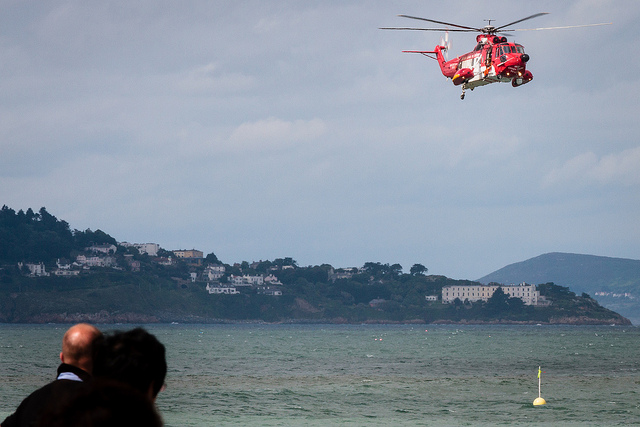<image>How high is the helicopter? It's uncertain how high the helicopter is, it could be anywhere from 50 to 500 feet. How high is the helicopter? It is unknown how high the helicopter is. It can be seen at different heights ranging from 50 feet to 500 feet. 